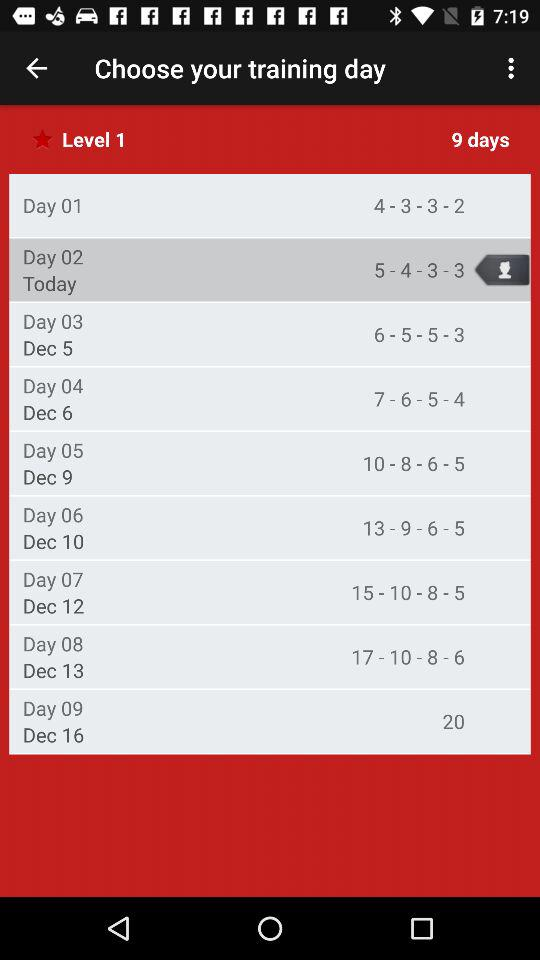What levels are on day 11?
When the provided information is insufficient, respond with <no answer>. <no answer> 